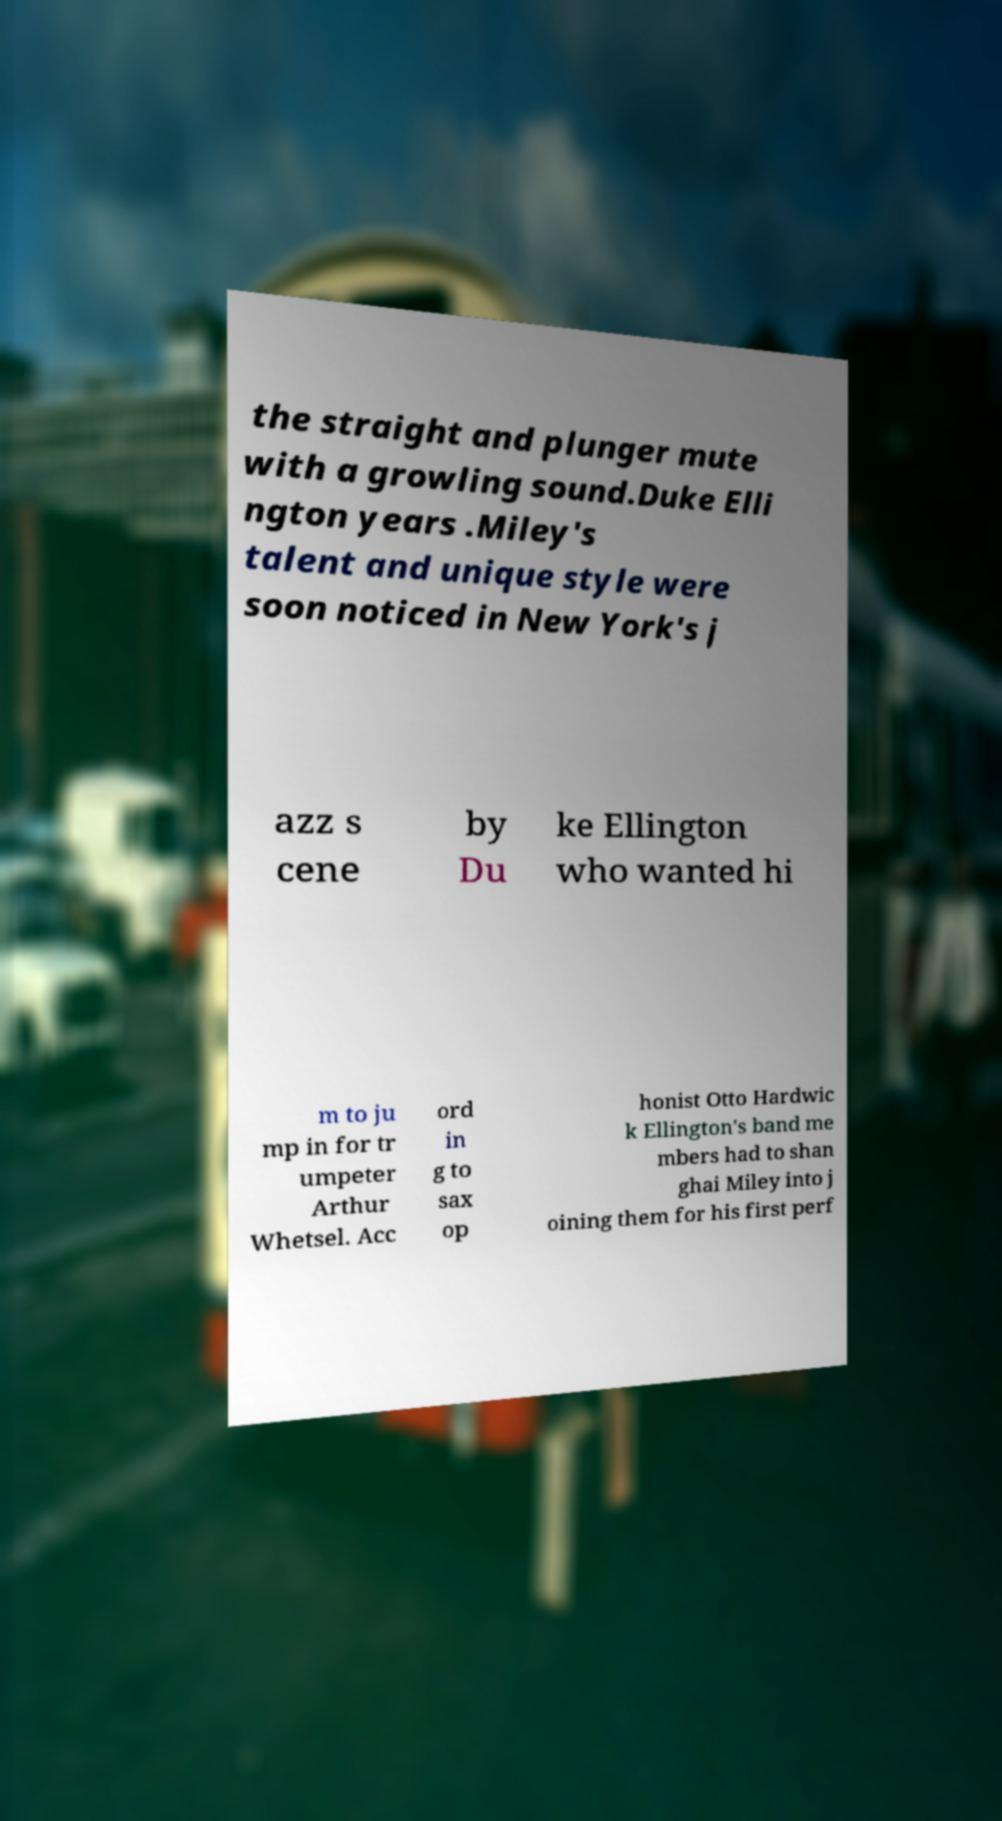Could you extract and type out the text from this image? the straight and plunger mute with a growling sound.Duke Elli ngton years .Miley's talent and unique style were soon noticed in New York's j azz s cene by Du ke Ellington who wanted hi m to ju mp in for tr umpeter Arthur Whetsel. Acc ord in g to sax op honist Otto Hardwic k Ellington's band me mbers had to shan ghai Miley into j oining them for his first perf 